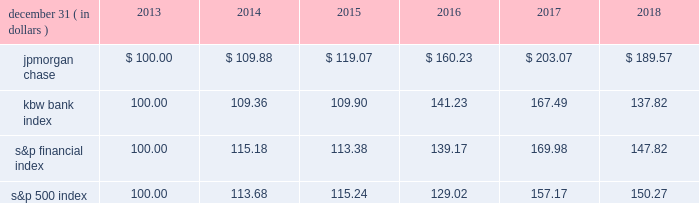Jpmorgan chase & co./2018 form 10-k 41 five-year stock performance the table and graph compare the five-year cumulative total return for jpmorgan chase & co .
( 201cjpmorgan chase 201d or the 201cfirm 201d ) common stock with the cumulative return of the s&p 500 index , the kbw bank index and the s&p financial index .
The s&p 500 index is a commonly referenced equity benchmark in the united states of america ( 201cu.s . 201d ) , consisting of leading companies from different economic sectors .
The kbw bank index seeks to reflect the performance of banks and thrifts that are publicly traded in the u.s .
And is composed of leading national money center and regional banks and thrifts .
The s&p financial index is an index of financial companies , all of which are components of the s&p 500 .
The firm is a component of all three industry indices .
The table and graph assume simultaneous investments of $ 100 on december 31 , 2013 , in jpmorgan chase common stock and in each of the above indices .
The comparison assumes that all dividends are reinvested .
December 31 , ( in dollars ) 2013 2014 2015 2016 2017 2018 .
December 31 , ( in dollars ) .
What is the estimated average return for the s&p financial index and the s&p 500 index in the firs year of the investment of $ 100? 
Rationale: its the average of the percentual return provided by each indice during the years 2013 and 2014 .
Computations: ((((115.18 / 100) - 1) + ((113.68 / 100) - 1)) / 2)
Answer: 0.1443. 